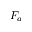Convert formula to latex. <formula><loc_0><loc_0><loc_500><loc_500>F _ { a }</formula> 